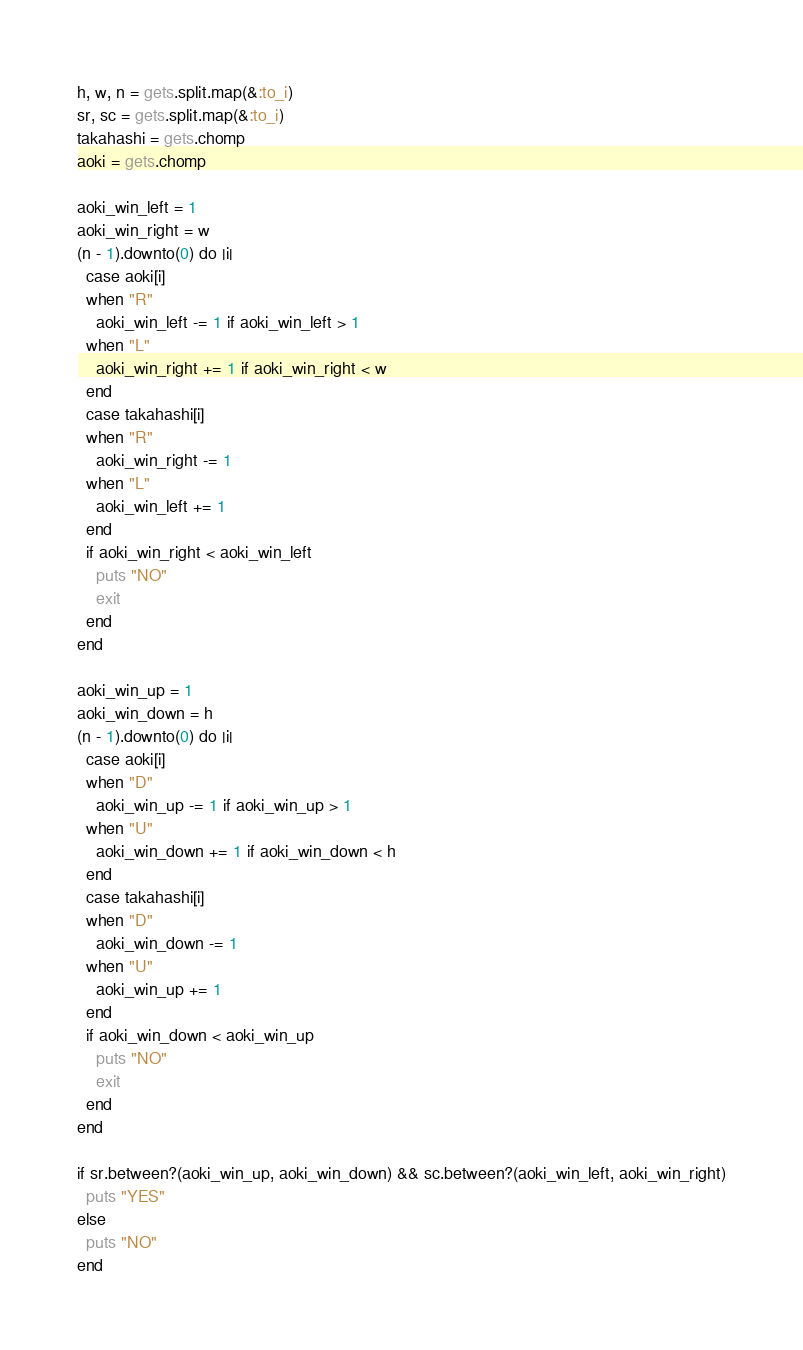Convert code to text. <code><loc_0><loc_0><loc_500><loc_500><_Ruby_>h, w, n = gets.split.map(&:to_i)
sr, sc = gets.split.map(&:to_i)
takahashi = gets.chomp
aoki = gets.chomp

aoki_win_left = 1
aoki_win_right = w
(n - 1).downto(0) do |i|
  case aoki[i]
  when "R"
    aoki_win_left -= 1 if aoki_win_left > 1
  when "L"
    aoki_win_right += 1 if aoki_win_right < w
  end
  case takahashi[i]
  when "R"
    aoki_win_right -= 1
  when "L"
    aoki_win_left += 1
  end
  if aoki_win_right < aoki_win_left
    puts "NO"
    exit
  end
end

aoki_win_up = 1
aoki_win_down = h
(n - 1).downto(0) do |i|
  case aoki[i]
  when "D"
    aoki_win_up -= 1 if aoki_win_up > 1
  when "U"
    aoki_win_down += 1 if aoki_win_down < h
  end
  case takahashi[i]
  when "D"
    aoki_win_down -= 1
  when "U"
    aoki_win_up += 1
  end
  if aoki_win_down < aoki_win_up
    puts "NO"
    exit
  end
end

if sr.between?(aoki_win_up, aoki_win_down) && sc.between?(aoki_win_left, aoki_win_right)
  puts "YES"
else
  puts "NO"
end
</code> 